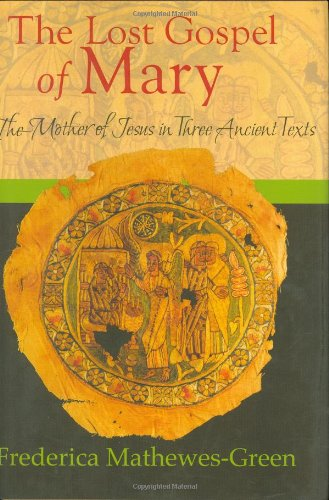Is this book related to Christian Books & Bibles? Yes, this book is indeed related to Christian Books & Bibles, offering a deep dive into the narratives and texts associated with Mary from a Christian theological perspective. 